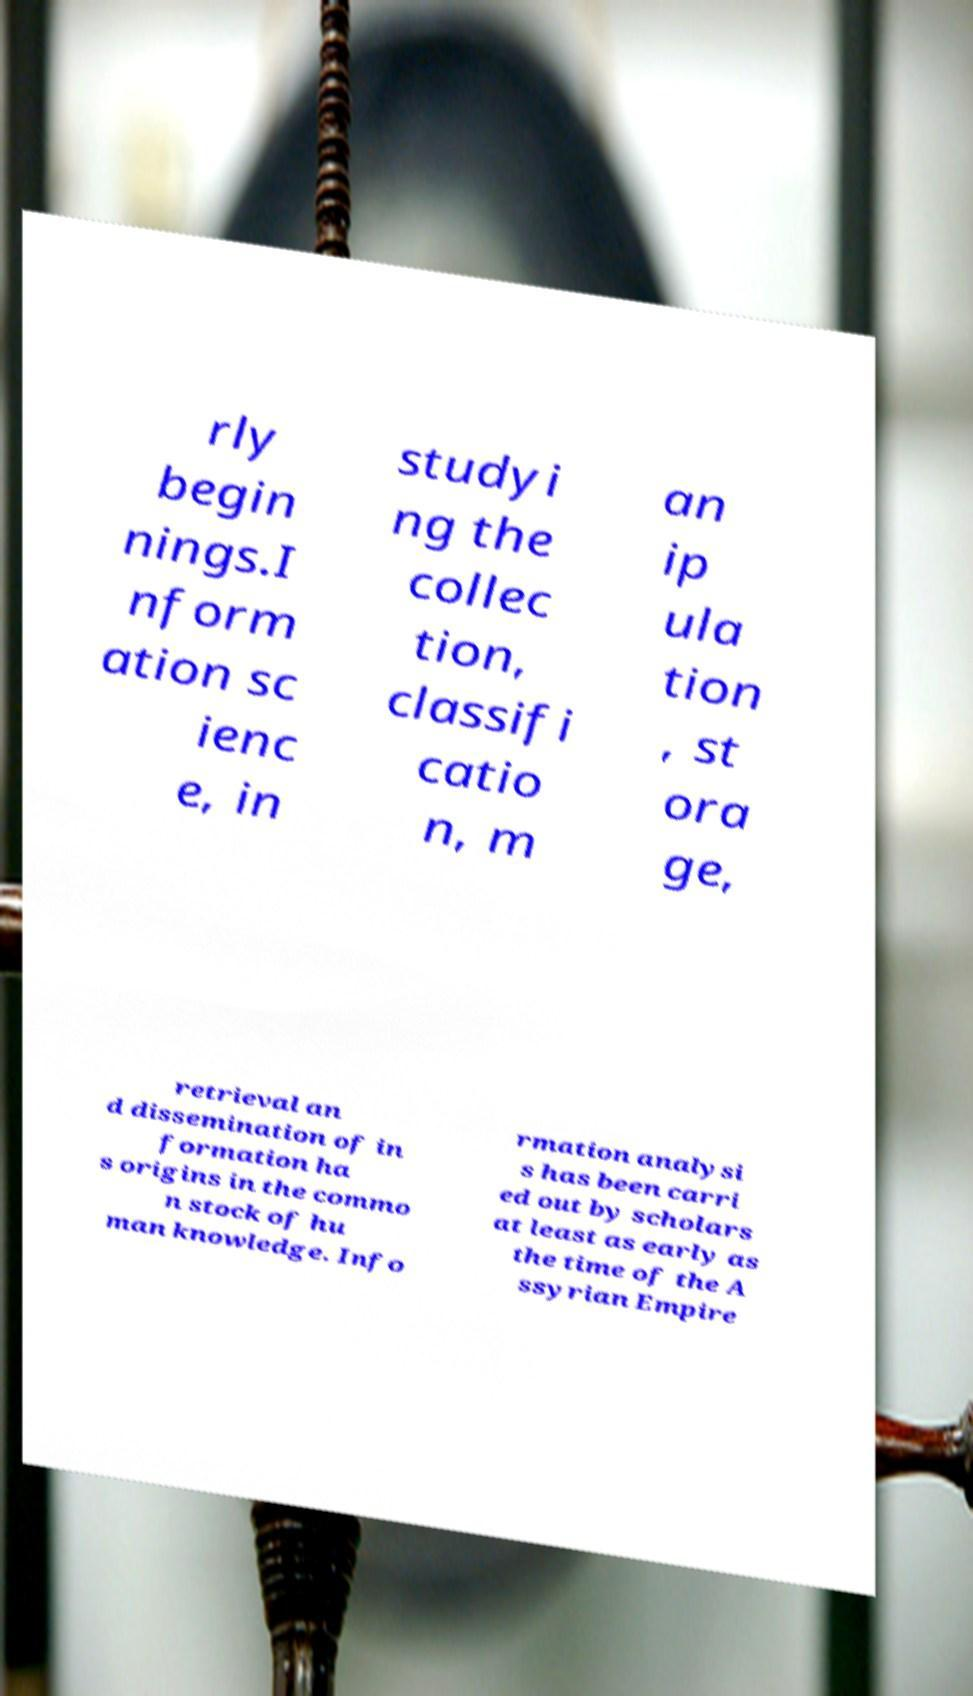What messages or text are displayed in this image? I need them in a readable, typed format. rly begin nings.I nform ation sc ienc e, in studyi ng the collec tion, classifi catio n, m an ip ula tion , st ora ge, retrieval an d dissemination of in formation ha s origins in the commo n stock of hu man knowledge. Info rmation analysi s has been carri ed out by scholars at least as early as the time of the A ssyrian Empire 